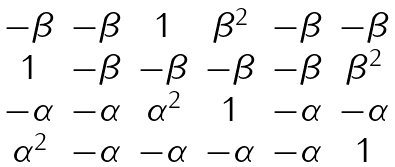Convert formula to latex. <formula><loc_0><loc_0><loc_500><loc_500>\begin{matrix} - \beta & - \beta & 1 & \beta ^ { 2 } & - \beta & - \beta \\ 1 & - \beta & - \beta & - \beta & - \beta & \beta ^ { 2 } \\ - \alpha & - \alpha & \alpha ^ { 2 } & 1 & - \alpha & - \alpha \\ \alpha ^ { 2 } & - \alpha & - \alpha & - \alpha & - \alpha & 1 \end{matrix}</formula> 